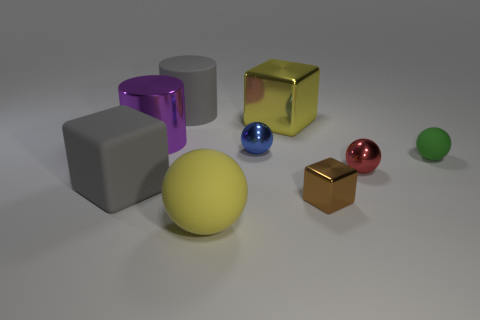Is the number of purple objects greater than the number of metal cubes?
Offer a terse response. No. There is a shiny ball that is behind the green rubber object that is behind the big yellow rubber thing; how big is it?
Keep it short and to the point. Small. There is another big thing that is the same shape as the big purple thing; what color is it?
Your answer should be very brief. Gray. The gray cylinder is what size?
Keep it short and to the point. Large. How many balls are big purple things or yellow shiny objects?
Offer a terse response. 0. What is the size of the yellow thing that is the same shape as the blue object?
Provide a short and direct response. Large. How many large purple metallic cylinders are there?
Ensure brevity in your answer.  1. There is a tiny blue shiny object; is it the same shape as the thing that is on the right side of the red ball?
Your answer should be very brief. Yes. There is a yellow thing on the left side of the tiny blue metal sphere; how big is it?
Offer a terse response. Large. What is the small green sphere made of?
Your response must be concise. Rubber. 